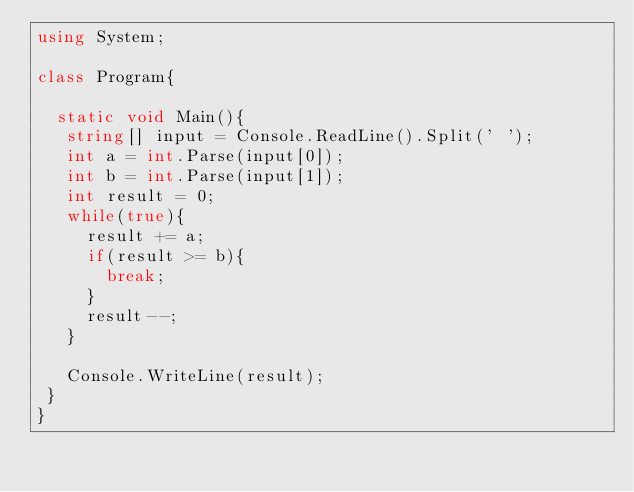<code> <loc_0><loc_0><loc_500><loc_500><_C#_>using System;

class Program{
  
  static void Main(){
   string[] input = Console.ReadLine().Split(' ');
   int a = int.Parse(input[0]);
   int b = int.Parse(input[1]); 
   int result = 0;
   while(true){
     result += a;
     if(result >= b){
       break; 
     }
     result--;
   }

   Console.WriteLine(result);
 }
}</code> 